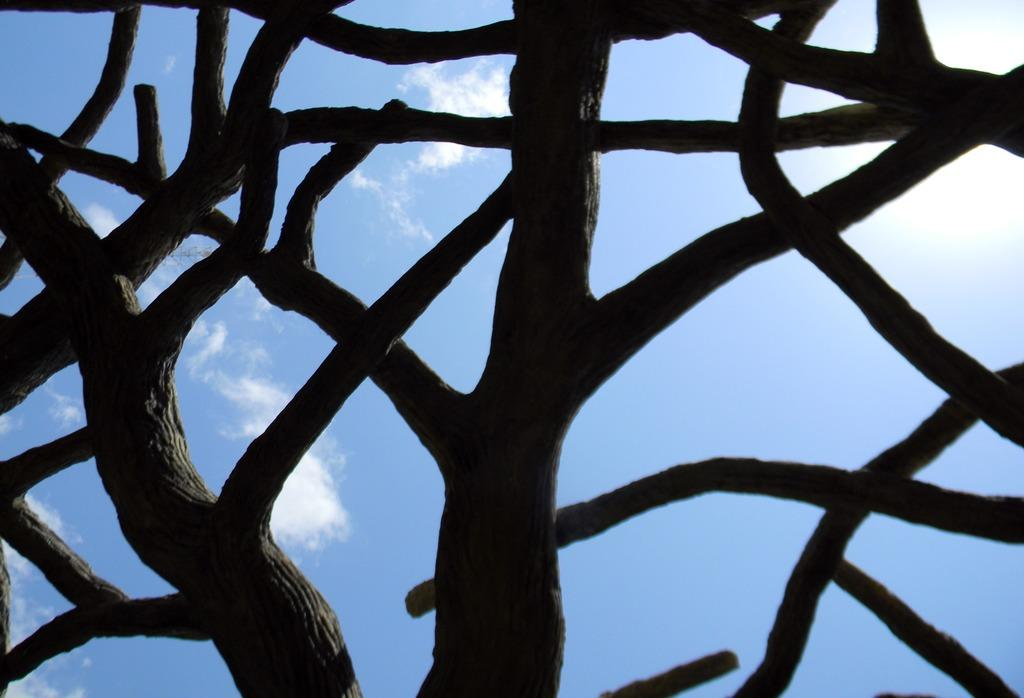What shapes can be seen in the image that resemble tree branches? There are shapes resembling tree branches in the image. What is visible at the top of the image? The sky is visible at the top of the image. How many chickens can be seen in the image? There are no chickens present in the image. What type of acoustics can be heard in the image? There is no sound or acoustics present in the image. 